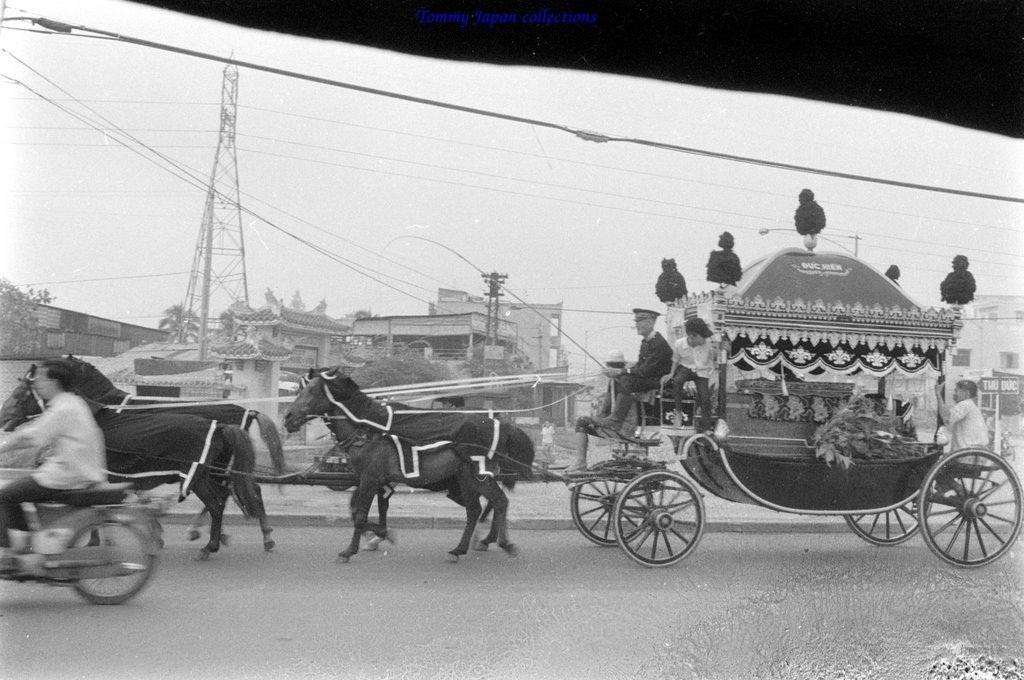How would you summarize this image in a sentence or two? This is a black and white picture. In this picture, we see men are riding the horse cart. On the left side, we see a man is riding the bike. At the bottom, we see the road. There are trees, buildings, tower, electric poles, street lights in the background. At the top, we see the sky and the wires. 